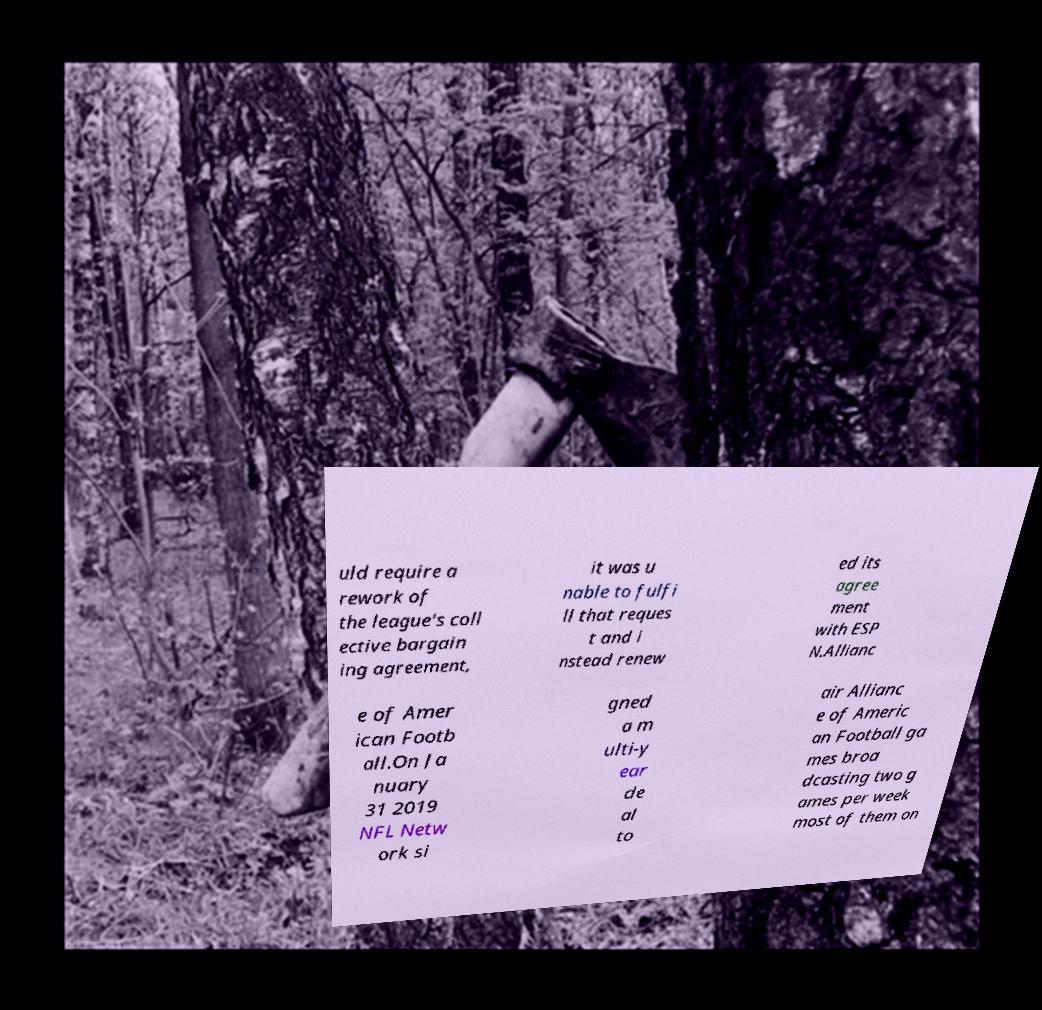I need the written content from this picture converted into text. Can you do that? uld require a rework of the league's coll ective bargain ing agreement, it was u nable to fulfi ll that reques t and i nstead renew ed its agree ment with ESP N.Allianc e of Amer ican Footb all.On Ja nuary 31 2019 NFL Netw ork si gned a m ulti-y ear de al to air Allianc e of Americ an Football ga mes broa dcasting two g ames per week most of them on 